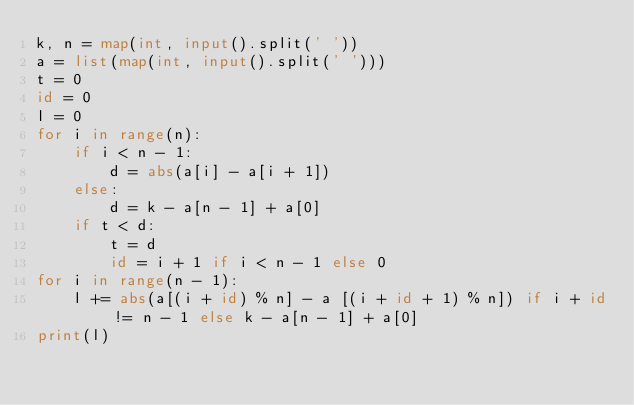<code> <loc_0><loc_0><loc_500><loc_500><_Python_>k, n = map(int, input().split(' '))
a = list(map(int, input().split(' ')))
t = 0
id = 0
l = 0
for i in range(n):
    if i < n - 1:
        d = abs(a[i] - a[i + 1])
    else:
        d = k - a[n - 1] + a[0]
    if t < d:
        t = d
        id = i + 1 if i < n - 1 else 0
for i in range(n - 1):
    l += abs(a[(i + id) % n] - a [(i + id + 1) % n]) if i + id != n - 1 else k - a[n - 1] + a[0]
print(l)</code> 